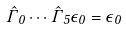Convert formula to latex. <formula><loc_0><loc_0><loc_500><loc_500>\hat { \Gamma } _ { 0 } \cdots \hat { \Gamma } _ { 5 } \epsilon _ { 0 } = \epsilon _ { 0 }</formula> 